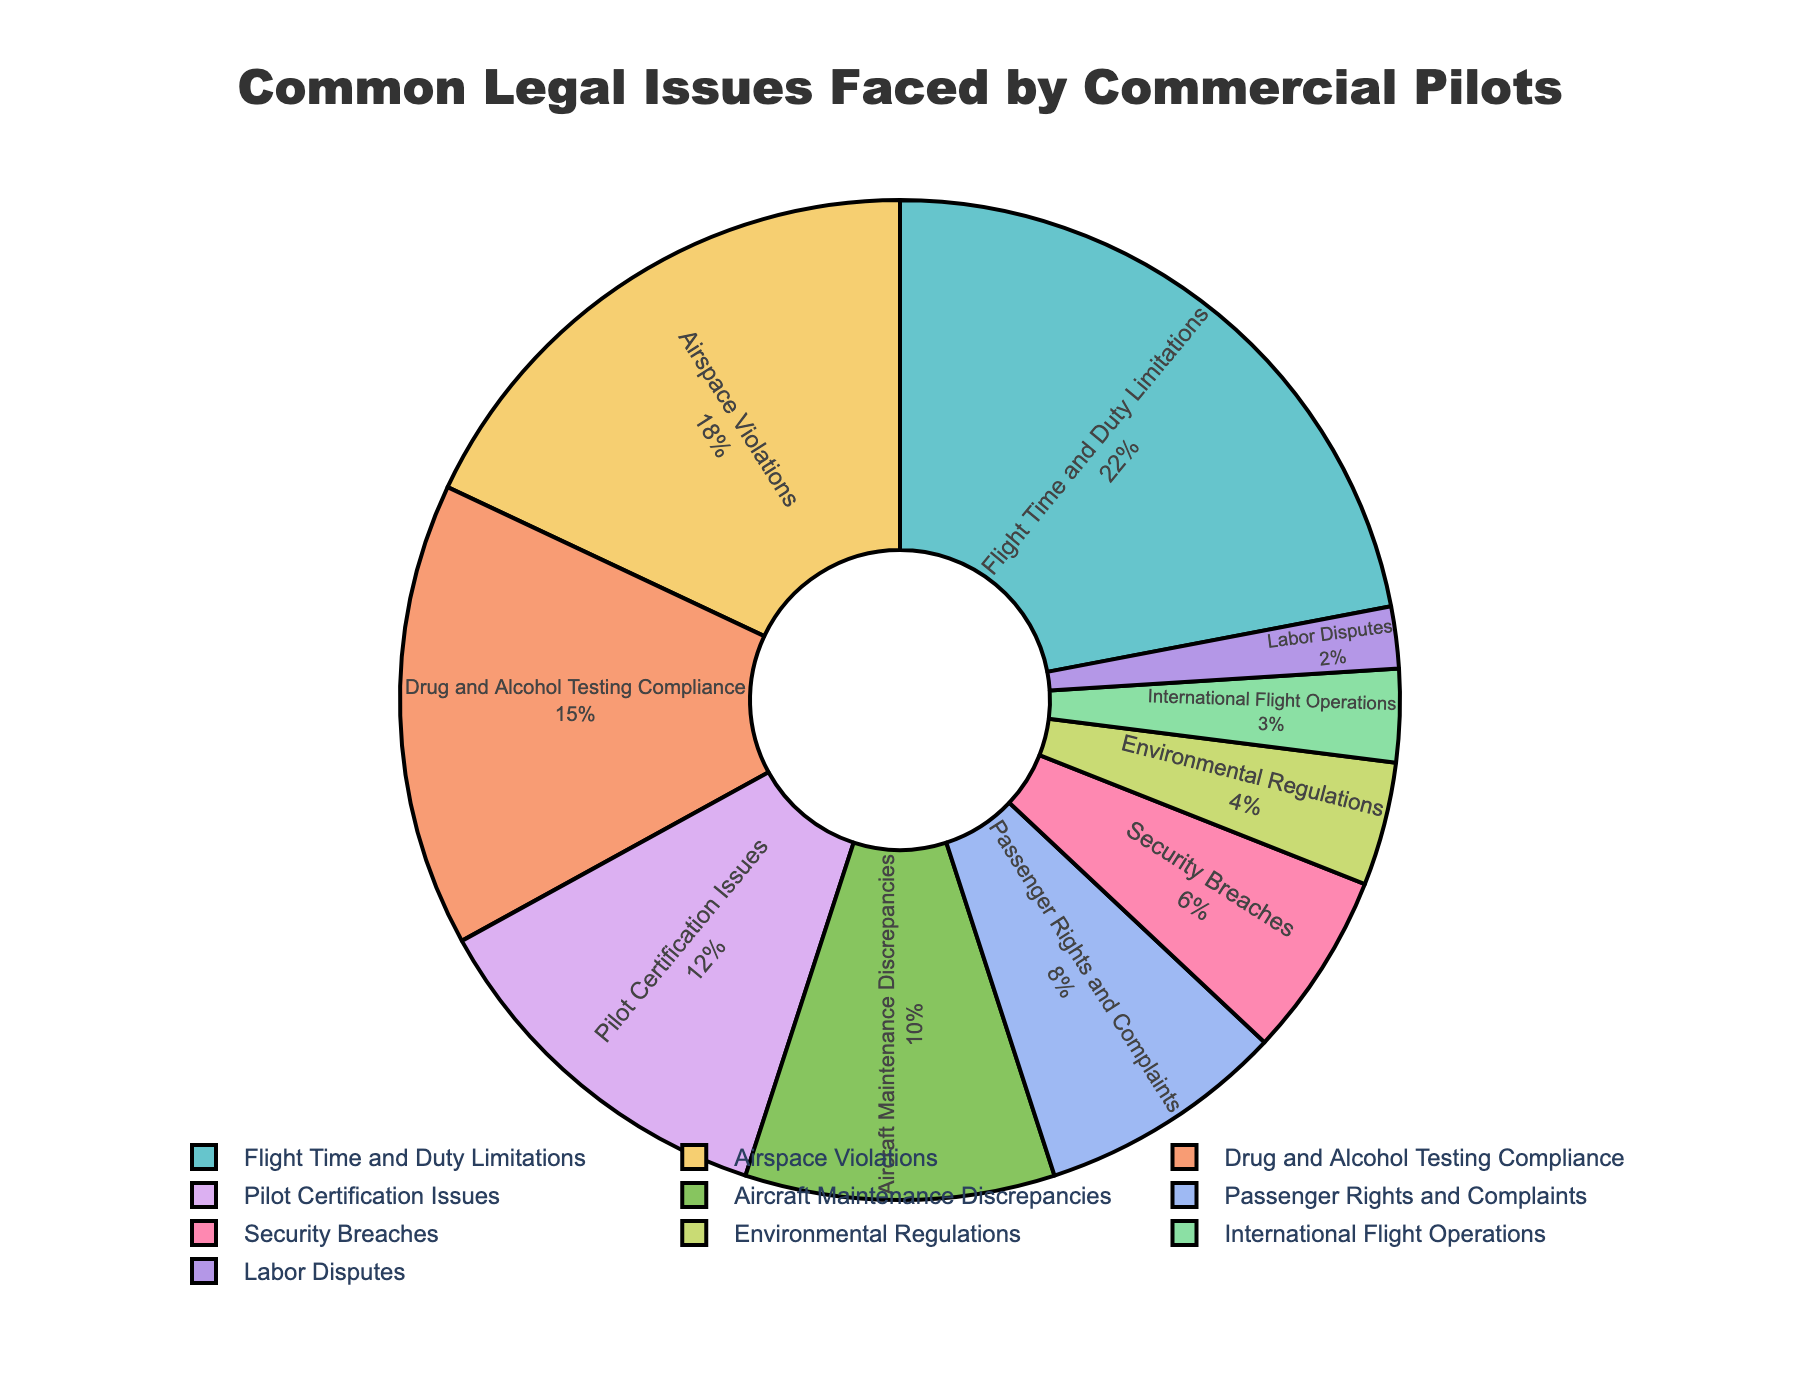Which category has the highest percentage of legal issues? The chart shows that "Flight Time and Duty Limitations" has the largest slice.
Answer: Flight Time and Duty Limitations How many categories have a percentage equal to or greater than 15%? By examining the percentages, "Flight Time and Duty Limitations," "Airspace Violations," and "Drug and Alcohol Testing Compliance" each have percentages equal to or greater than 15%.
Answer: 3 What is the difference in percentage between the category with the highest and the second-highest percentages? The highest percentage is "Flight Time and Duty Limitations" at 22%, and the second-highest is "Airspace Violations" at 18%. The difference is 22% - 18% = 4%.
Answer: 4% Which two categories combined make up the highest total percentage? Summing the percentages, "Flight Time and Duty Limitations" (22%) and "Airspace Violations" (18%) combine for a total of 40%, which is the highest combined percentage.
Answer: Flight Time and Duty Limitations, Airspace Violations What is the average percentage of all the categories? Summing all percentages (22 + 18 + 15 + 12 + 10 + 8 + 6 + 4 + 3 + 2 = 100) and then dividing by the number of categories (10) gives an average of 100 / 10 = 10%.
Answer: 10% Which category has a percentage exactly half of "Flight Time and Duty Limitations"? "Flight Time and Duty Limitations" is 22%, and the category with 11% would be half. However, no category has 11%. Therefore, no category matches this condition.
Answer: None Which category shows the least percentage and what is its value? The smallest slice appears under "Labor Disputes" with a percentage of 2%.
Answer: Labor Disputes, 2% What is the total percentage of categories related to pilot-specific issues (Flight Time and Duty Limitations, Drug and Alcohol Testing Compliance, Pilot Certification Issues)? Summing the percentages for these categories: 22% + 15% + 12% = 49%.
Answer: 49% If the slices corresponding to "Passenger Rights and Complaints" and "Security Breaches" were merged, what would their combined percentage be? Summing the percentages of "Passenger Rights and Complaints" (8%) and "Security Breaches" (6%) results in 8% + 6% = 14%.
Answer: 14% How much more prevalent are "Aircraft Maintenance Discrepancies" than "International Flight Operations"? The percentage for "Aircraft Maintenance Discrepancies" is 10%, and for "International Flight Operations," it is 3%. The difference is 10% - 3% = 7%.
Answer: 7% 